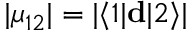<formula> <loc_0><loc_0><loc_500><loc_500>| \mu _ { 1 2 } | = | \langle 1 | d | 2 \rangle |</formula> 